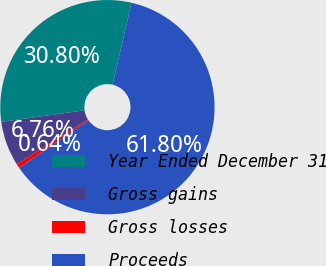Convert chart to OTSL. <chart><loc_0><loc_0><loc_500><loc_500><pie_chart><fcel>Year Ended December 31<fcel>Gross gains<fcel>Gross losses<fcel>Proceeds<nl><fcel>30.8%<fcel>6.76%<fcel>0.64%<fcel>61.8%<nl></chart> 